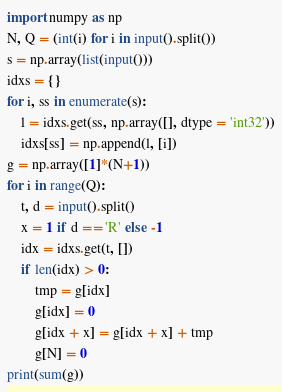<code> <loc_0><loc_0><loc_500><loc_500><_Python_>import numpy as np
N, Q = (int(i) for i in input().split())  
s = np.array(list(input()))
idxs = {}
for i, ss in enumerate(s):
    l = idxs.get(ss, np.array([], dtype = 'int32'))
    idxs[ss] = np.append(l, [i])
g = np.array([1]*(N+1))
for i in range(Q):
    t, d = input().split()
    x = 1 if d == 'R' else -1
    idx = idxs.get(t, [])
    if len(idx) > 0:
        tmp = g[idx]
        g[idx] = 0
        g[idx + x] = g[idx + x] + tmp
        g[N] = 0
print(sum(g))</code> 